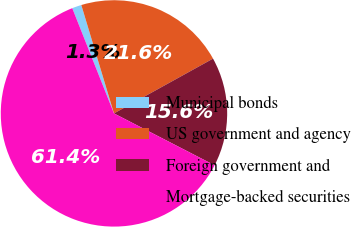Convert chart to OTSL. <chart><loc_0><loc_0><loc_500><loc_500><pie_chart><fcel>Municipal bonds<fcel>US government and agency<fcel>Foreign government and<fcel>Mortgage-backed securities<nl><fcel>1.35%<fcel>21.62%<fcel>15.62%<fcel>61.42%<nl></chart> 